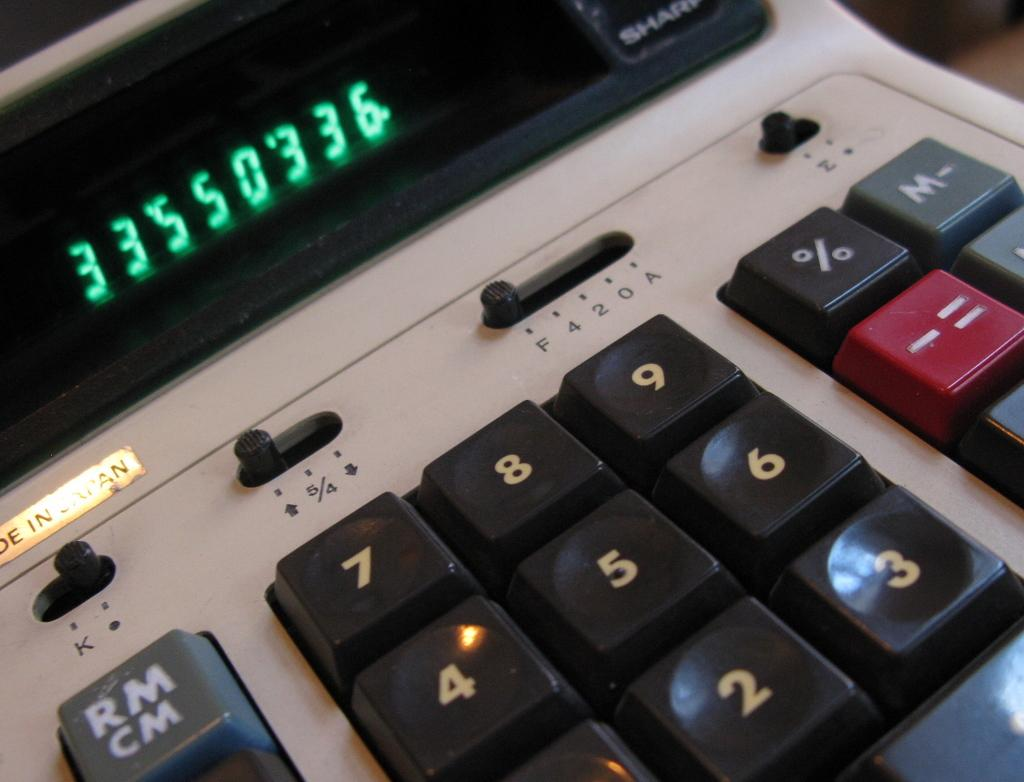<image>
Provide a brief description of the given image. 33550336 is shown on the digital display of this calculator. 